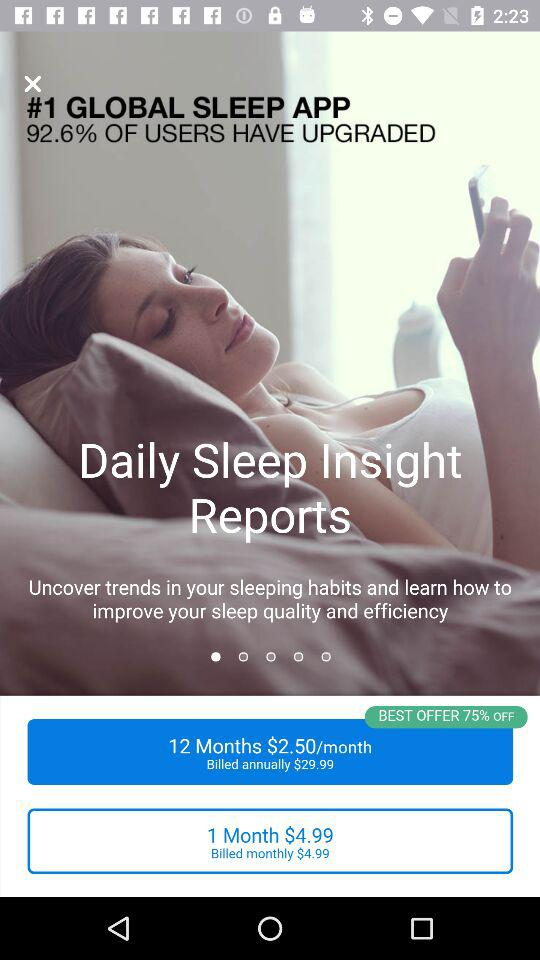What is the amount per month if billed annually? The amount per month if billed annually is $2.50. 